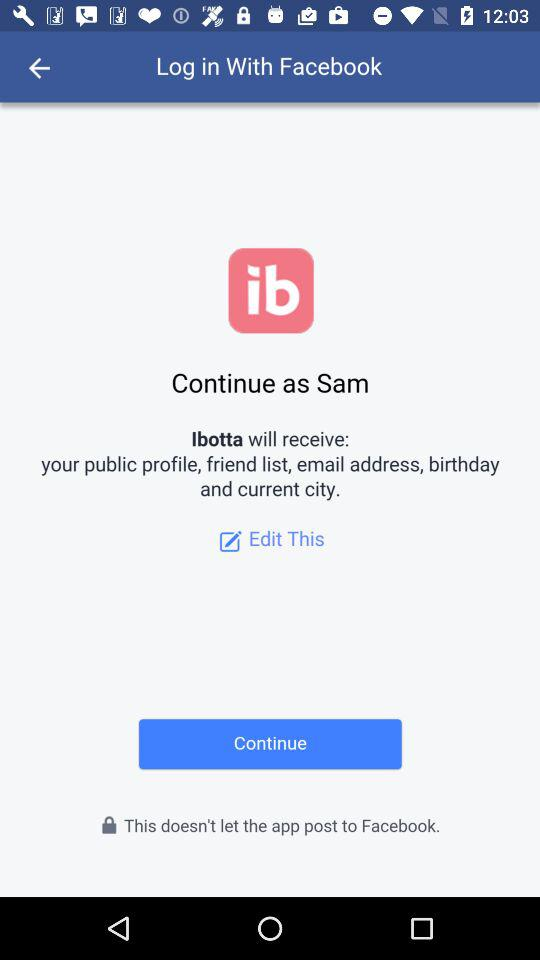What application is asking for permission? The application asking for permission is "Ibotta". 